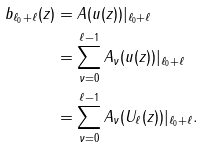<formula> <loc_0><loc_0><loc_500><loc_500>b _ { \ell _ { 0 } + \ell } ( z ) & = A ( u ( z ) ) | _ { \ell _ { 0 } + \ell } \\ & = \sum _ { \nu = 0 } ^ { \ell - 1 } A _ { \nu } ( u ( z ) ) | _ { \ell _ { 0 } + \ell } \\ & = \sum _ { \nu = 0 } ^ { \ell - 1 } A _ { \nu } ( U _ { \ell } ( z ) ) | _ { \ell _ { 0 } + \ell } . \\</formula> 